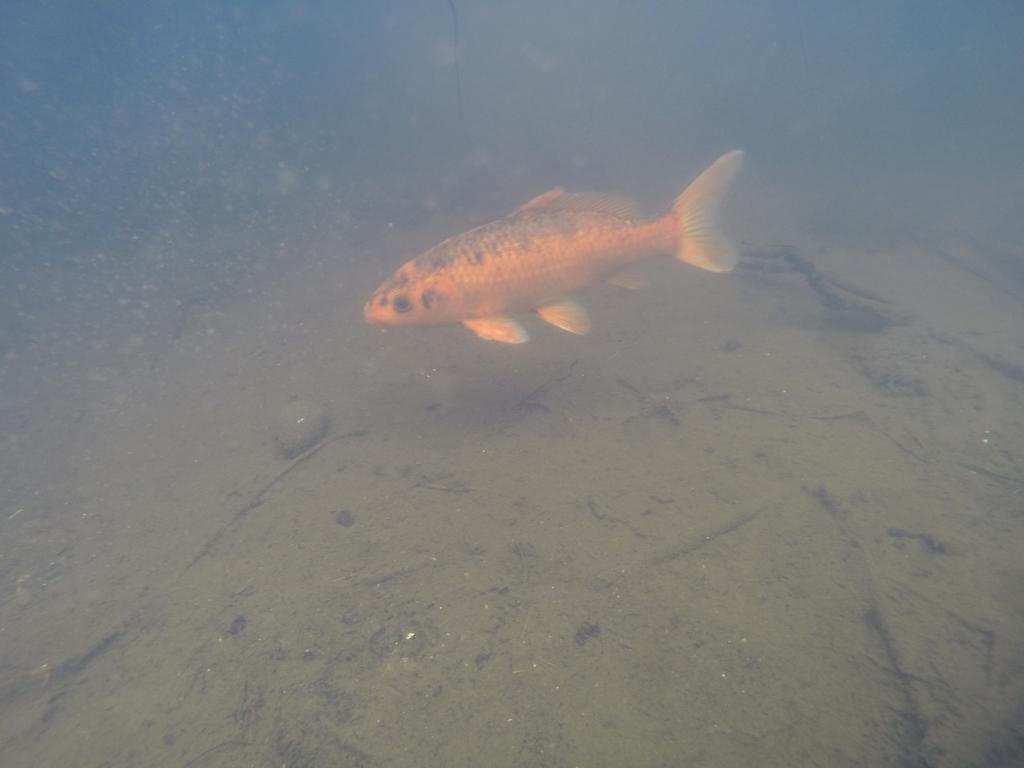Could you give a brief overview of what you see in this image? In this image I can see a orange color fish inside the water. I can see sand,few sticks and stone. Back I can see a blue color background. 